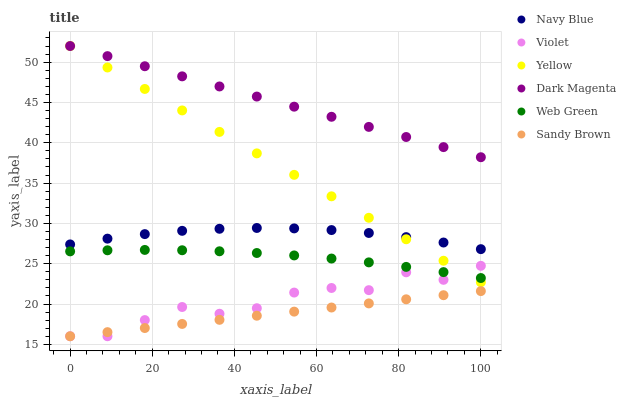Does Sandy Brown have the minimum area under the curve?
Answer yes or no. Yes. Does Dark Magenta have the maximum area under the curve?
Answer yes or no. Yes. Does Navy Blue have the minimum area under the curve?
Answer yes or no. No. Does Navy Blue have the maximum area under the curve?
Answer yes or no. No. Is Sandy Brown the smoothest?
Answer yes or no. Yes. Is Violet the roughest?
Answer yes or no. Yes. Is Navy Blue the smoothest?
Answer yes or no. No. Is Navy Blue the roughest?
Answer yes or no. No. Does Violet have the lowest value?
Answer yes or no. Yes. Does Navy Blue have the lowest value?
Answer yes or no. No. Does Yellow have the highest value?
Answer yes or no. Yes. Does Navy Blue have the highest value?
Answer yes or no. No. Is Navy Blue less than Dark Magenta?
Answer yes or no. Yes. Is Dark Magenta greater than Web Green?
Answer yes or no. Yes. Does Violet intersect Web Green?
Answer yes or no. Yes. Is Violet less than Web Green?
Answer yes or no. No. Is Violet greater than Web Green?
Answer yes or no. No. Does Navy Blue intersect Dark Magenta?
Answer yes or no. No. 